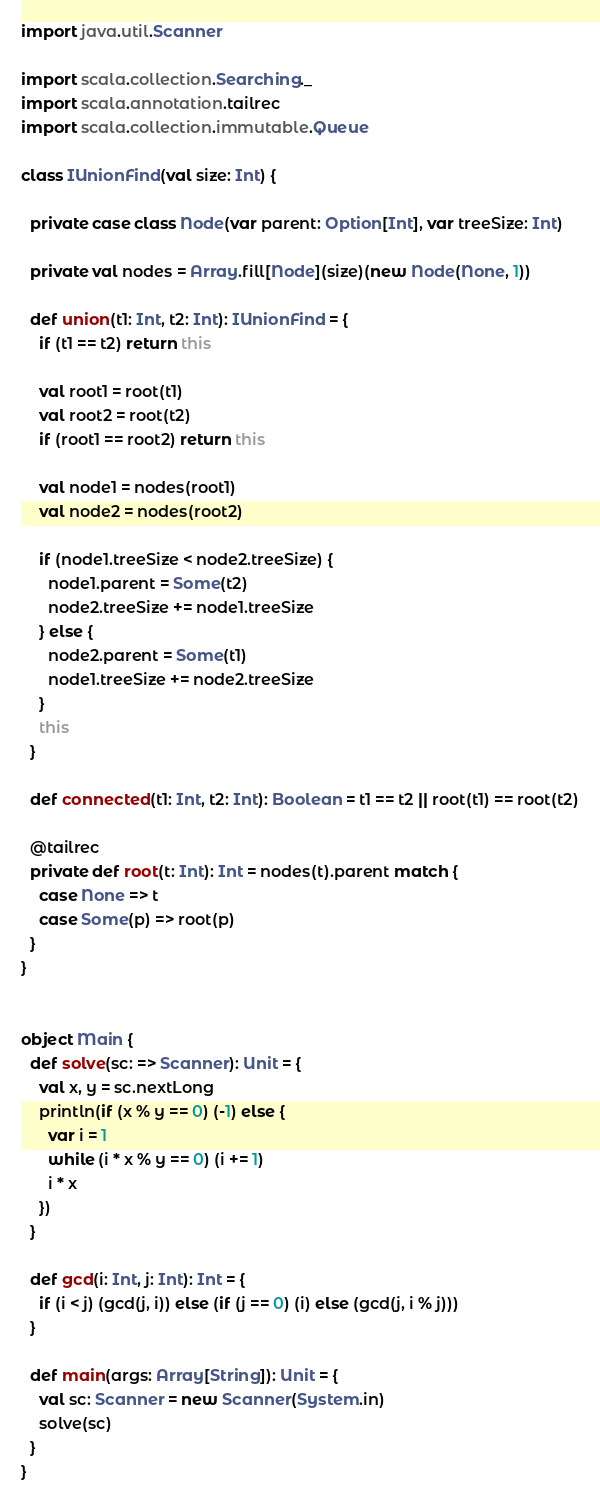Convert code to text. <code><loc_0><loc_0><loc_500><loc_500><_Scala_>import java.util.Scanner

import scala.collection.Searching._
import scala.annotation.tailrec
import scala.collection.immutable.Queue

class IUnionFind(val size: Int) {

  private case class Node(var parent: Option[Int], var treeSize: Int)

  private val nodes = Array.fill[Node](size)(new Node(None, 1))

  def union(t1: Int, t2: Int): IUnionFind = {
    if (t1 == t2) return this

    val root1 = root(t1)
    val root2 = root(t2)
    if (root1 == root2) return this

    val node1 = nodes(root1)
    val node2 = nodes(root2)

    if (node1.treeSize < node2.treeSize) {
      node1.parent = Some(t2)
      node2.treeSize += node1.treeSize
    } else {
      node2.parent = Some(t1)
      node1.treeSize += node2.treeSize
    }
    this
  }

  def connected(t1: Int, t2: Int): Boolean = t1 == t2 || root(t1) == root(t2)

  @tailrec
  private def root(t: Int): Int = nodes(t).parent match {
    case None => t
    case Some(p) => root(p)
  }
}


object Main {
  def solve(sc: => Scanner): Unit = {
    val x, y = sc.nextLong
    println(if (x % y == 0) (-1) else {
      var i = 1
      while (i * x % y == 0) (i += 1)
      i * x
    })
  }

  def gcd(i: Int, j: Int): Int = {
    if (i < j) (gcd(j, i)) else (if (j == 0) (i) else (gcd(j, i % j)))
  }

  def main(args: Array[String]): Unit = {
    val sc: Scanner = new Scanner(System.in)
    solve(sc)
  }
}

</code> 